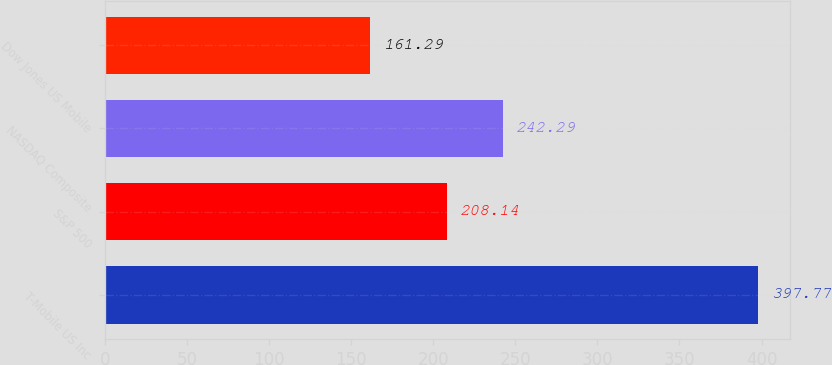Convert chart. <chart><loc_0><loc_0><loc_500><loc_500><bar_chart><fcel>T-Mobile US Inc<fcel>S&P 500<fcel>NASDAQ Composite<fcel>Dow Jones US Mobile<nl><fcel>397.77<fcel>208.14<fcel>242.29<fcel>161.29<nl></chart> 